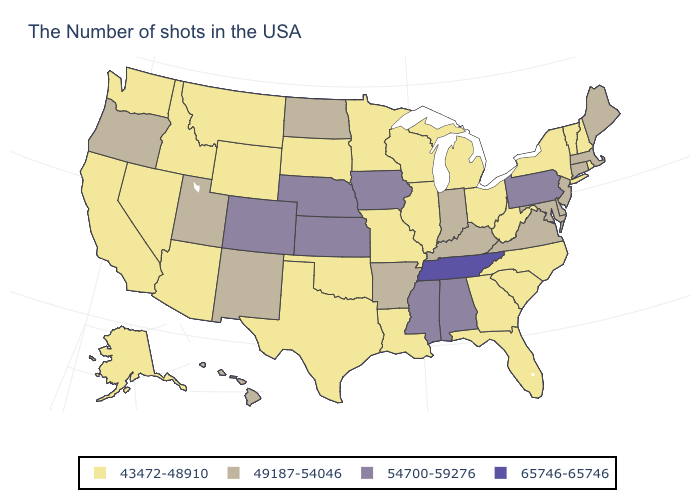What is the lowest value in the Northeast?
Concise answer only. 43472-48910. Is the legend a continuous bar?
Give a very brief answer. No. Does the first symbol in the legend represent the smallest category?
Write a very short answer. Yes. Does the map have missing data?
Short answer required. No. Does the first symbol in the legend represent the smallest category?
Write a very short answer. Yes. Does Maine have the lowest value in the USA?
Quick response, please. No. Is the legend a continuous bar?
Keep it brief. No. What is the value of Illinois?
Keep it brief. 43472-48910. What is the value of West Virginia?
Answer briefly. 43472-48910. Does Tennessee have the highest value in the South?
Concise answer only. Yes. Does Virginia have the highest value in the South?
Quick response, please. No. What is the value of Indiana?
Be succinct. 49187-54046. What is the lowest value in states that border Texas?
Keep it brief. 43472-48910. What is the value of New Jersey?
Short answer required. 49187-54046. Name the states that have a value in the range 54700-59276?
Be succinct. Pennsylvania, Alabama, Mississippi, Iowa, Kansas, Nebraska, Colorado. 